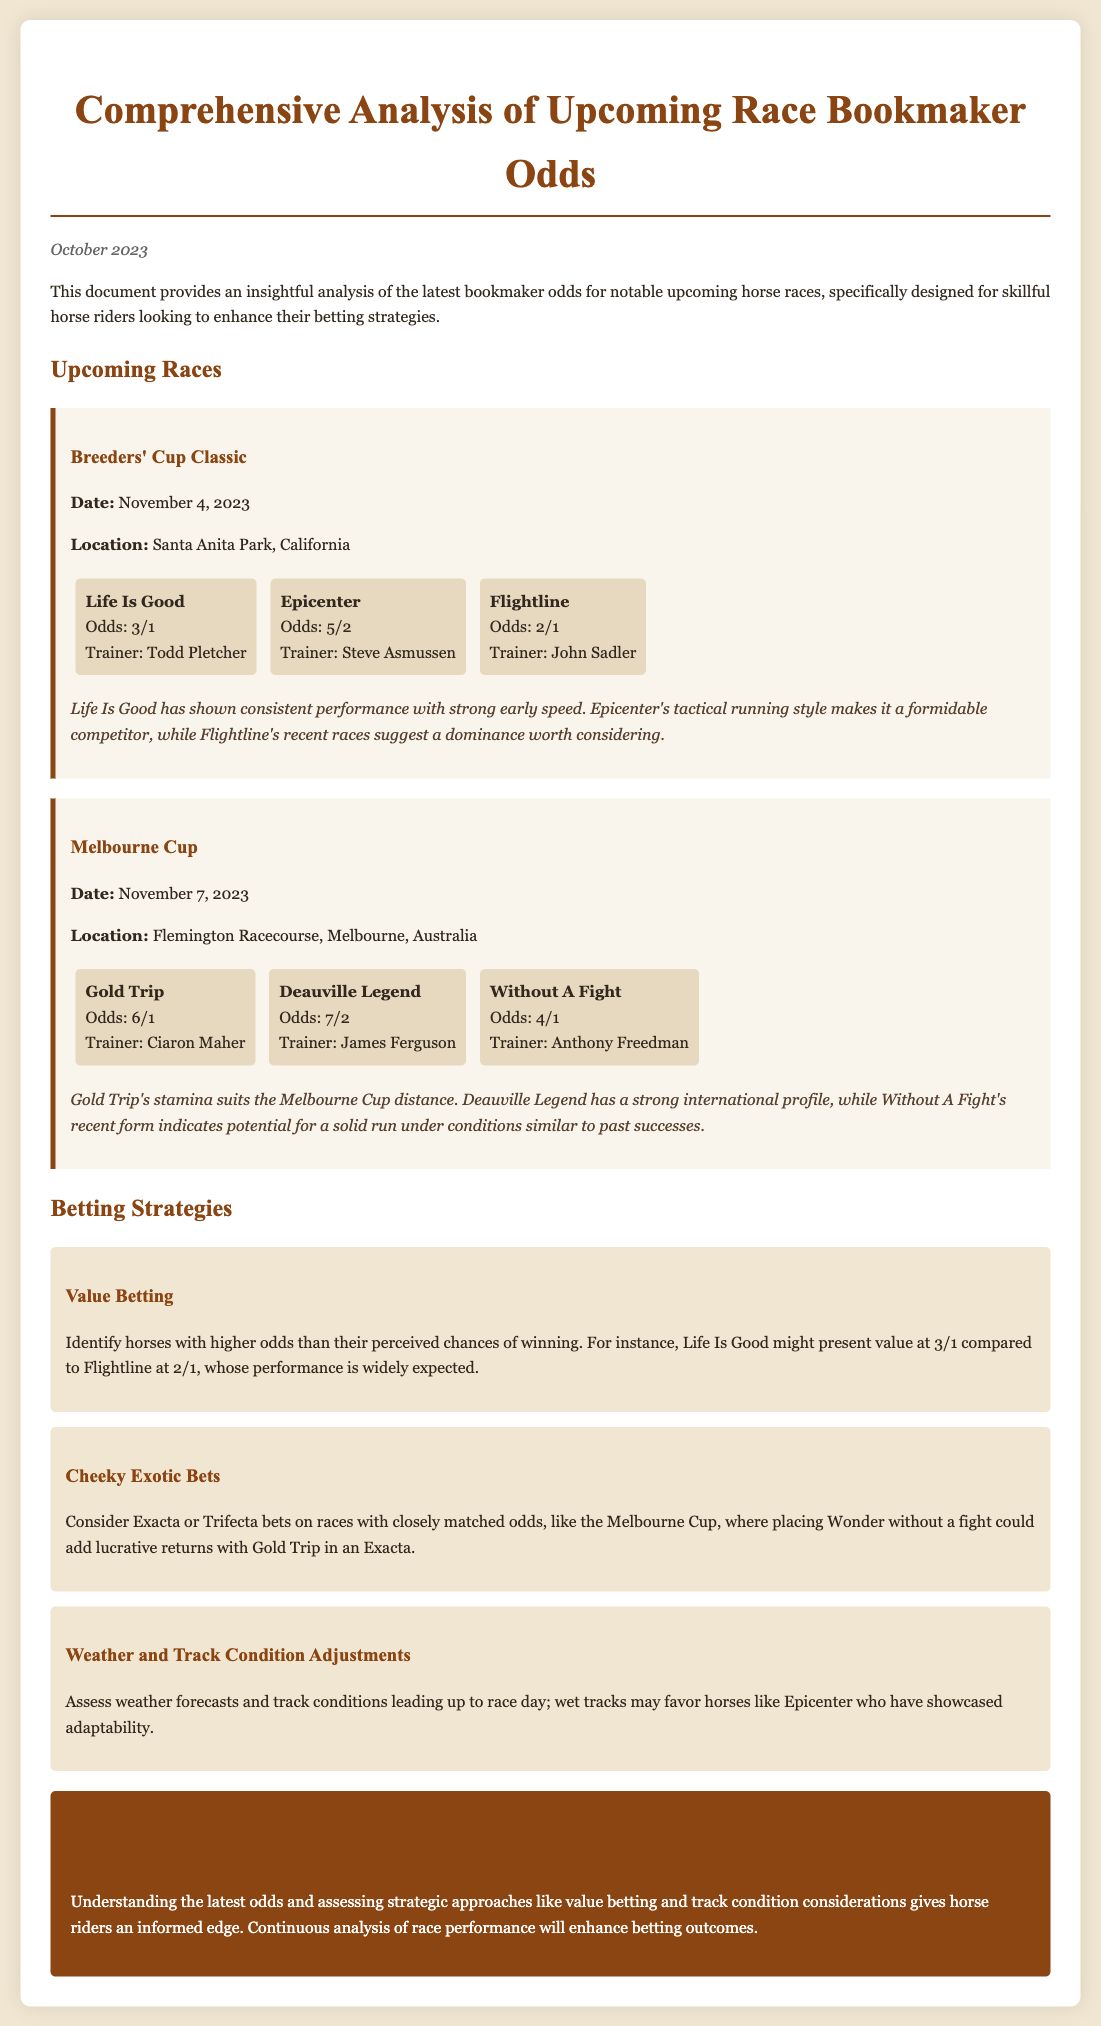What is the date of the Breeders' Cup Classic? The date of the Breeders' Cup Classic is specified in the document as November 4, 2023.
Answer: November 4, 2023 Who is the trainer of Epicenter? The document states that the trainer of Epicenter is Steve Asmussen.
Answer: Steve Asmussen What is the odds for Flightline? Flightline's odds are mentioned in the document as 2/1.
Answer: 2/1 Which horse is noted for showing strong early speed? The horse noted for showing strong early speed in the document is Life Is Good.
Answer: Life Is Good What type of betting strategy involves identifying horses with higher odds than their perceived chances? The betting strategy that entails this approach is referred to as Value Betting.
Answer: Value Betting Which race is scheduled to take place at Flemington Racecourse? The race scheduled to take place at Flemington Racecourse is the Melbourne Cup.
Answer: Melbourne Cup What is the suggested adjustment for betting related to weather conditions? The suggested adjustment for betting is to assess weather forecasts and track conditions.
Answer: Assess weather forecasts and track conditions Which horse is highlighted for its stamina suitable for the Melbourne Cup distance? The horse highlighted for its stamina suited to the Melbourne Cup distance is Gold Trip.
Answer: Gold Trip 